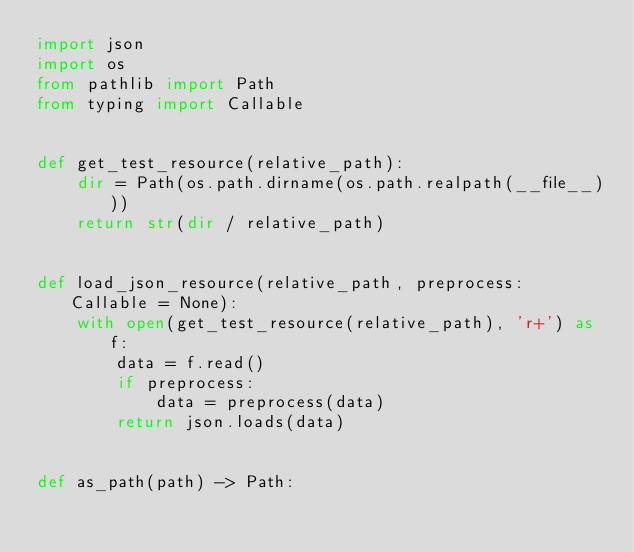Convert code to text. <code><loc_0><loc_0><loc_500><loc_500><_Python_>import json
import os
from pathlib import Path
from typing import Callable


def get_test_resource(relative_path):
    dir = Path(os.path.dirname(os.path.realpath(__file__)))
    return str(dir / relative_path)


def load_json_resource(relative_path, preprocess: Callable = None):
    with open(get_test_resource(relative_path), 'r+') as f:
        data = f.read()
        if preprocess:
            data = preprocess(data)
        return json.loads(data)


def as_path(path) -> Path:</code> 